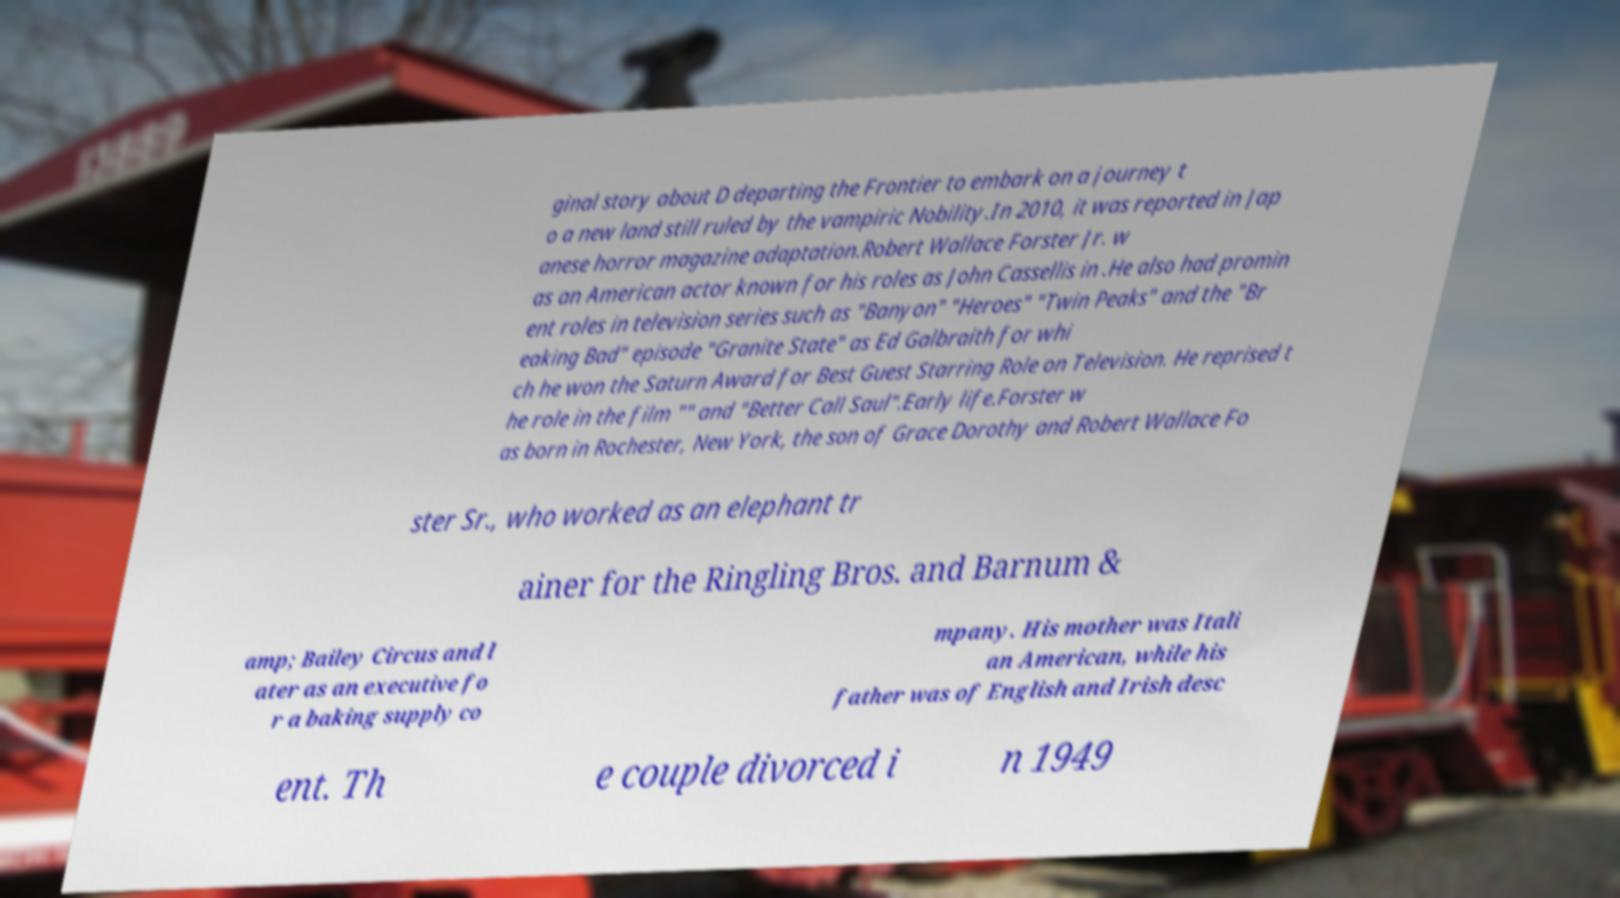Could you extract and type out the text from this image? ginal story about D departing the Frontier to embark on a journey t o a new land still ruled by the vampiric Nobility.In 2010, it was reported in Jap anese horror magazine adaptation.Robert Wallace Forster Jr. w as an American actor known for his roles as John Cassellis in .He also had promin ent roles in television series such as "Banyon" "Heroes" "Twin Peaks" and the "Br eaking Bad" episode "Granite State" as Ed Galbraith for whi ch he won the Saturn Award for Best Guest Starring Role on Television. He reprised t he role in the film "" and "Better Call Saul".Early life.Forster w as born in Rochester, New York, the son of Grace Dorothy and Robert Wallace Fo ster Sr., who worked as an elephant tr ainer for the Ringling Bros. and Barnum & amp; Bailey Circus and l ater as an executive fo r a baking supply co mpany. His mother was Itali an American, while his father was of English and Irish desc ent. Th e couple divorced i n 1949 